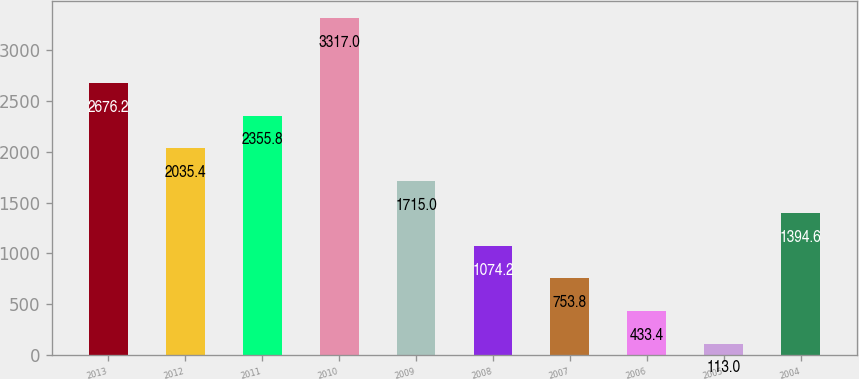Convert chart to OTSL. <chart><loc_0><loc_0><loc_500><loc_500><bar_chart><fcel>2013<fcel>2012<fcel>2011<fcel>2010<fcel>2009<fcel>2008<fcel>2007<fcel>2006<fcel>2005<fcel>2004<nl><fcel>2676.2<fcel>2035.4<fcel>2355.8<fcel>3317<fcel>1715<fcel>1074.2<fcel>753.8<fcel>433.4<fcel>113<fcel>1394.6<nl></chart> 